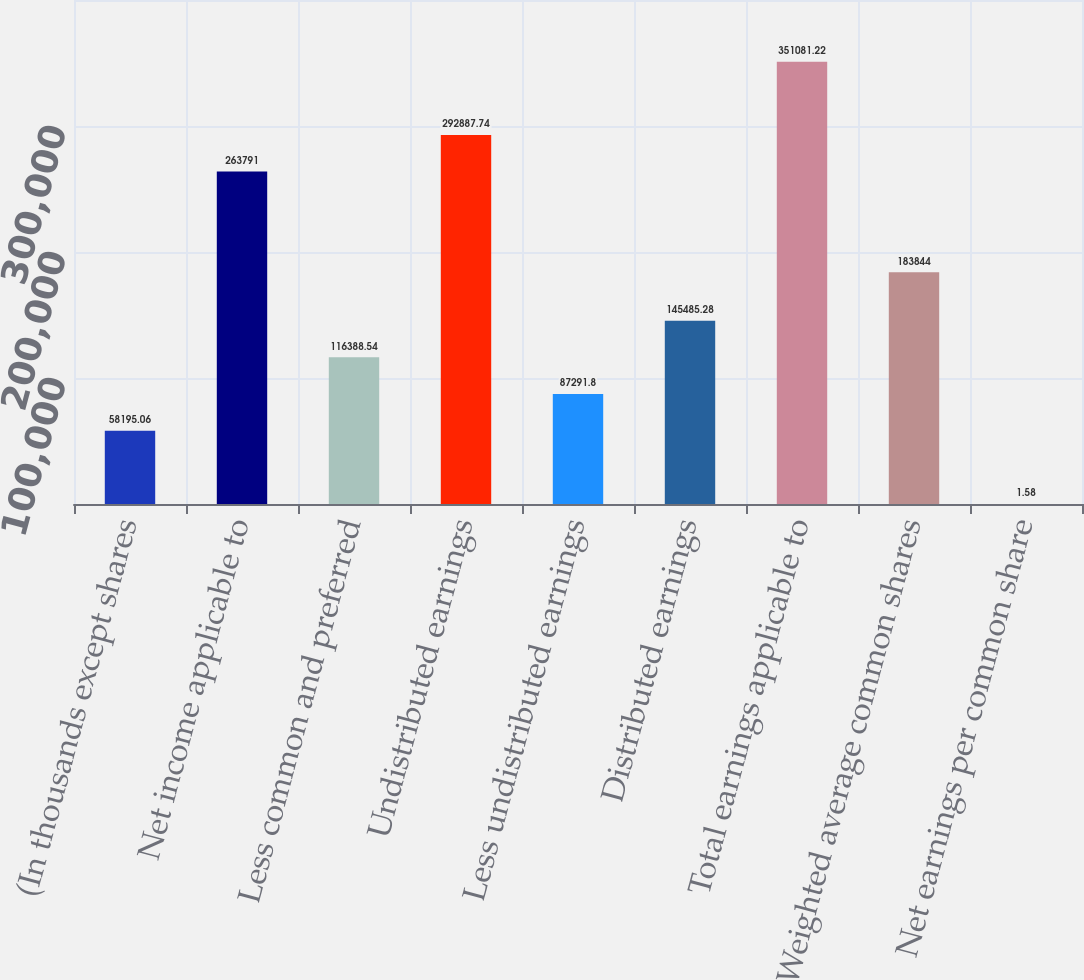<chart> <loc_0><loc_0><loc_500><loc_500><bar_chart><fcel>(In thousands except shares<fcel>Net income applicable to<fcel>Less common and preferred<fcel>Undistributed earnings<fcel>Less undistributed earnings<fcel>Distributed earnings<fcel>Total earnings applicable to<fcel>Weighted average common shares<fcel>Net earnings per common share<nl><fcel>58195.1<fcel>263791<fcel>116389<fcel>292888<fcel>87291.8<fcel>145485<fcel>351081<fcel>183844<fcel>1.58<nl></chart> 